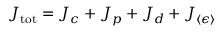<formula> <loc_0><loc_0><loc_500><loc_500>J _ { t o t } = J _ { c } + J _ { p } + J _ { d } + J _ { \langle \epsilon \rangle }</formula> 